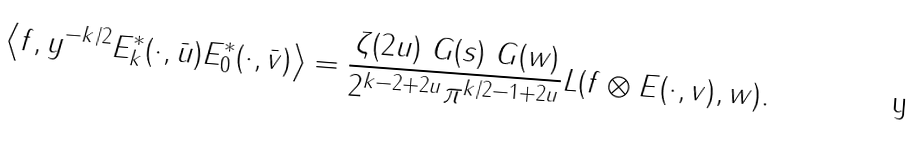<formula> <loc_0><loc_0><loc_500><loc_500>\left \langle f , y ^ { - k / 2 } E ^ { * } _ { k } ( \cdot , \bar { u } ) E ^ { * } _ { 0 } ( \cdot , \bar { v } ) \right \rangle = \frac { \zeta ( 2 u ) \ G ( s ) \ G ( w ) } { 2 ^ { k - 2 + 2 u } \pi ^ { k / 2 - 1 + 2 u } } L ( f \otimes E ( \cdot , v ) , w ) .</formula> 